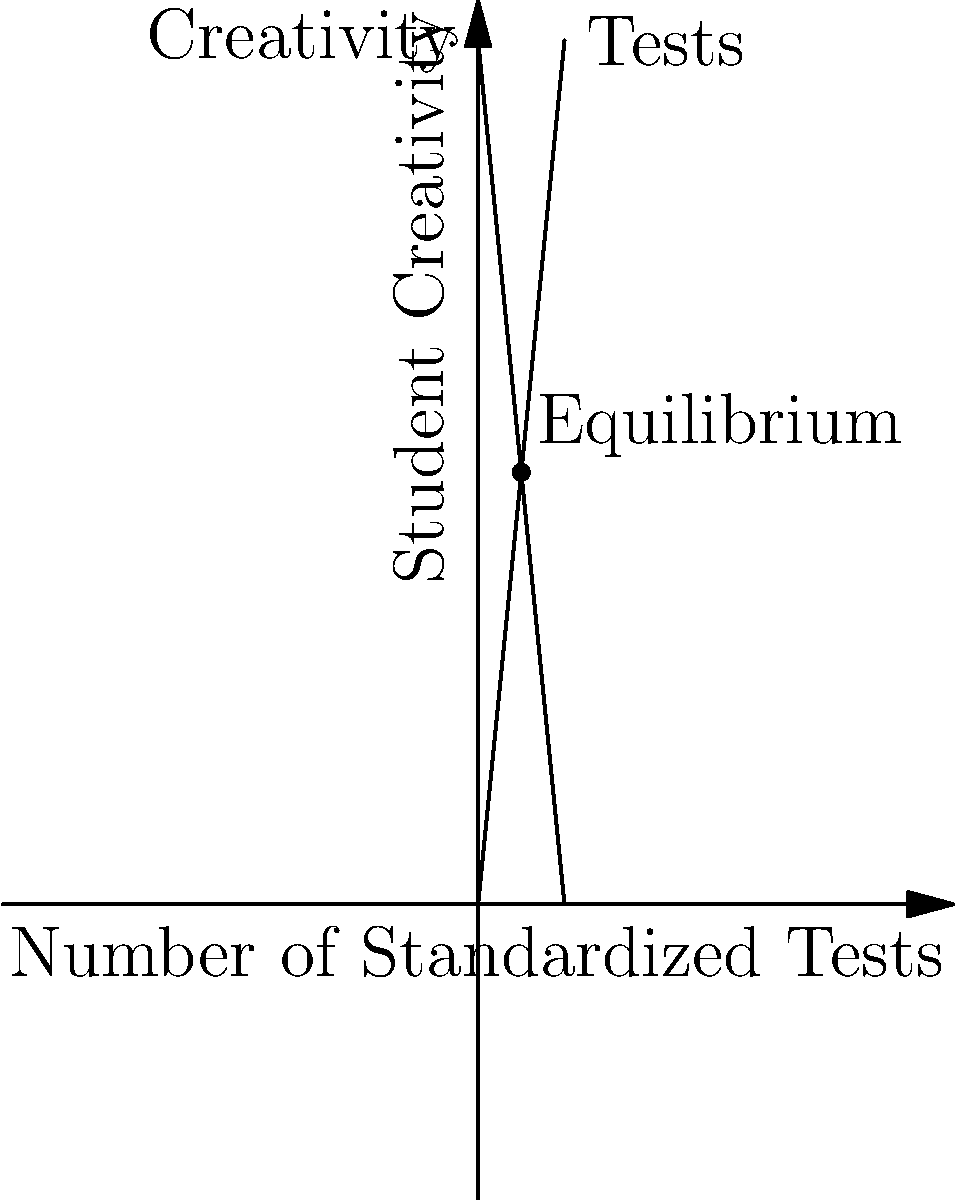In the graph above, the line representing student creativity intersects with the line representing the number of standardized tests. If this were a real-world scenario, what would you call the point where these lines meet, and how might it relate to the current state of our education system? Let's break this down step-by-step:

1. The graph shows two intersecting lines: one representing student creativity and the other representing the number of standardized tests.

2. These lines have an inverse relationship, meaning as one increases, the other decreases.

3. The point where these lines intersect is called the equilibrium point. In economics, this is where supply meets demand.

4. In our education "comedy," this equilibrium point represents a balance between creativity and standardized testing.

5. However, this "balance" might not be ideal. It suggests that increasing standardized tests decreases creativity, and vice versa.

6. In the context of our education system, this equilibrium could be seen as the "Bureaucratic Sweet Spot" - the point where administrators have maximized testing while minimizing creative thinking.

7. From a comedian's perspective, this could be called the "Creativity Killing Compromise" or the "Test-Induced Talent Terminator."
Answer: The Bureaucratic Sweet Spot 